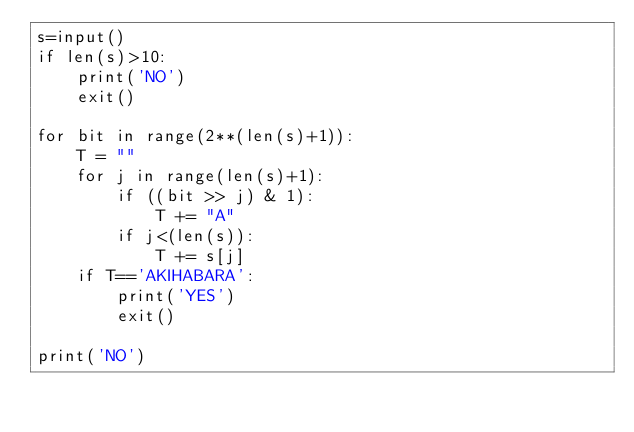Convert code to text. <code><loc_0><loc_0><loc_500><loc_500><_Python_>s=input()
if len(s)>10:
    print('NO')
    exit()

for bit in range(2**(len(s)+1)):
    T = ""
    for j in range(len(s)+1):
        if ((bit >> j) & 1):
            T += "A"
        if j<(len(s)):
            T += s[j]
    if T=='AKIHABARA':
        print('YES')
        exit()

print('NO')    </code> 